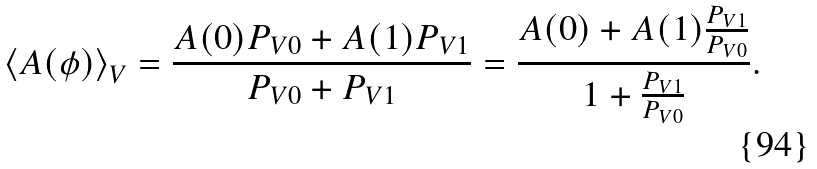Convert formula to latex. <formula><loc_0><loc_0><loc_500><loc_500>\left \langle A ( \phi ) \right \rangle _ { V } = \frac { A ( 0 ) P _ { V 0 } + A ( 1 ) P _ { V 1 } } { P _ { V 0 } + P _ { V 1 } } = \frac { A ( 0 ) + A ( 1 ) \frac { P _ { V 1 } } { P _ { V 0 } } } { 1 + \frac { P _ { V 1 } } { P _ { V 0 } } } .</formula> 